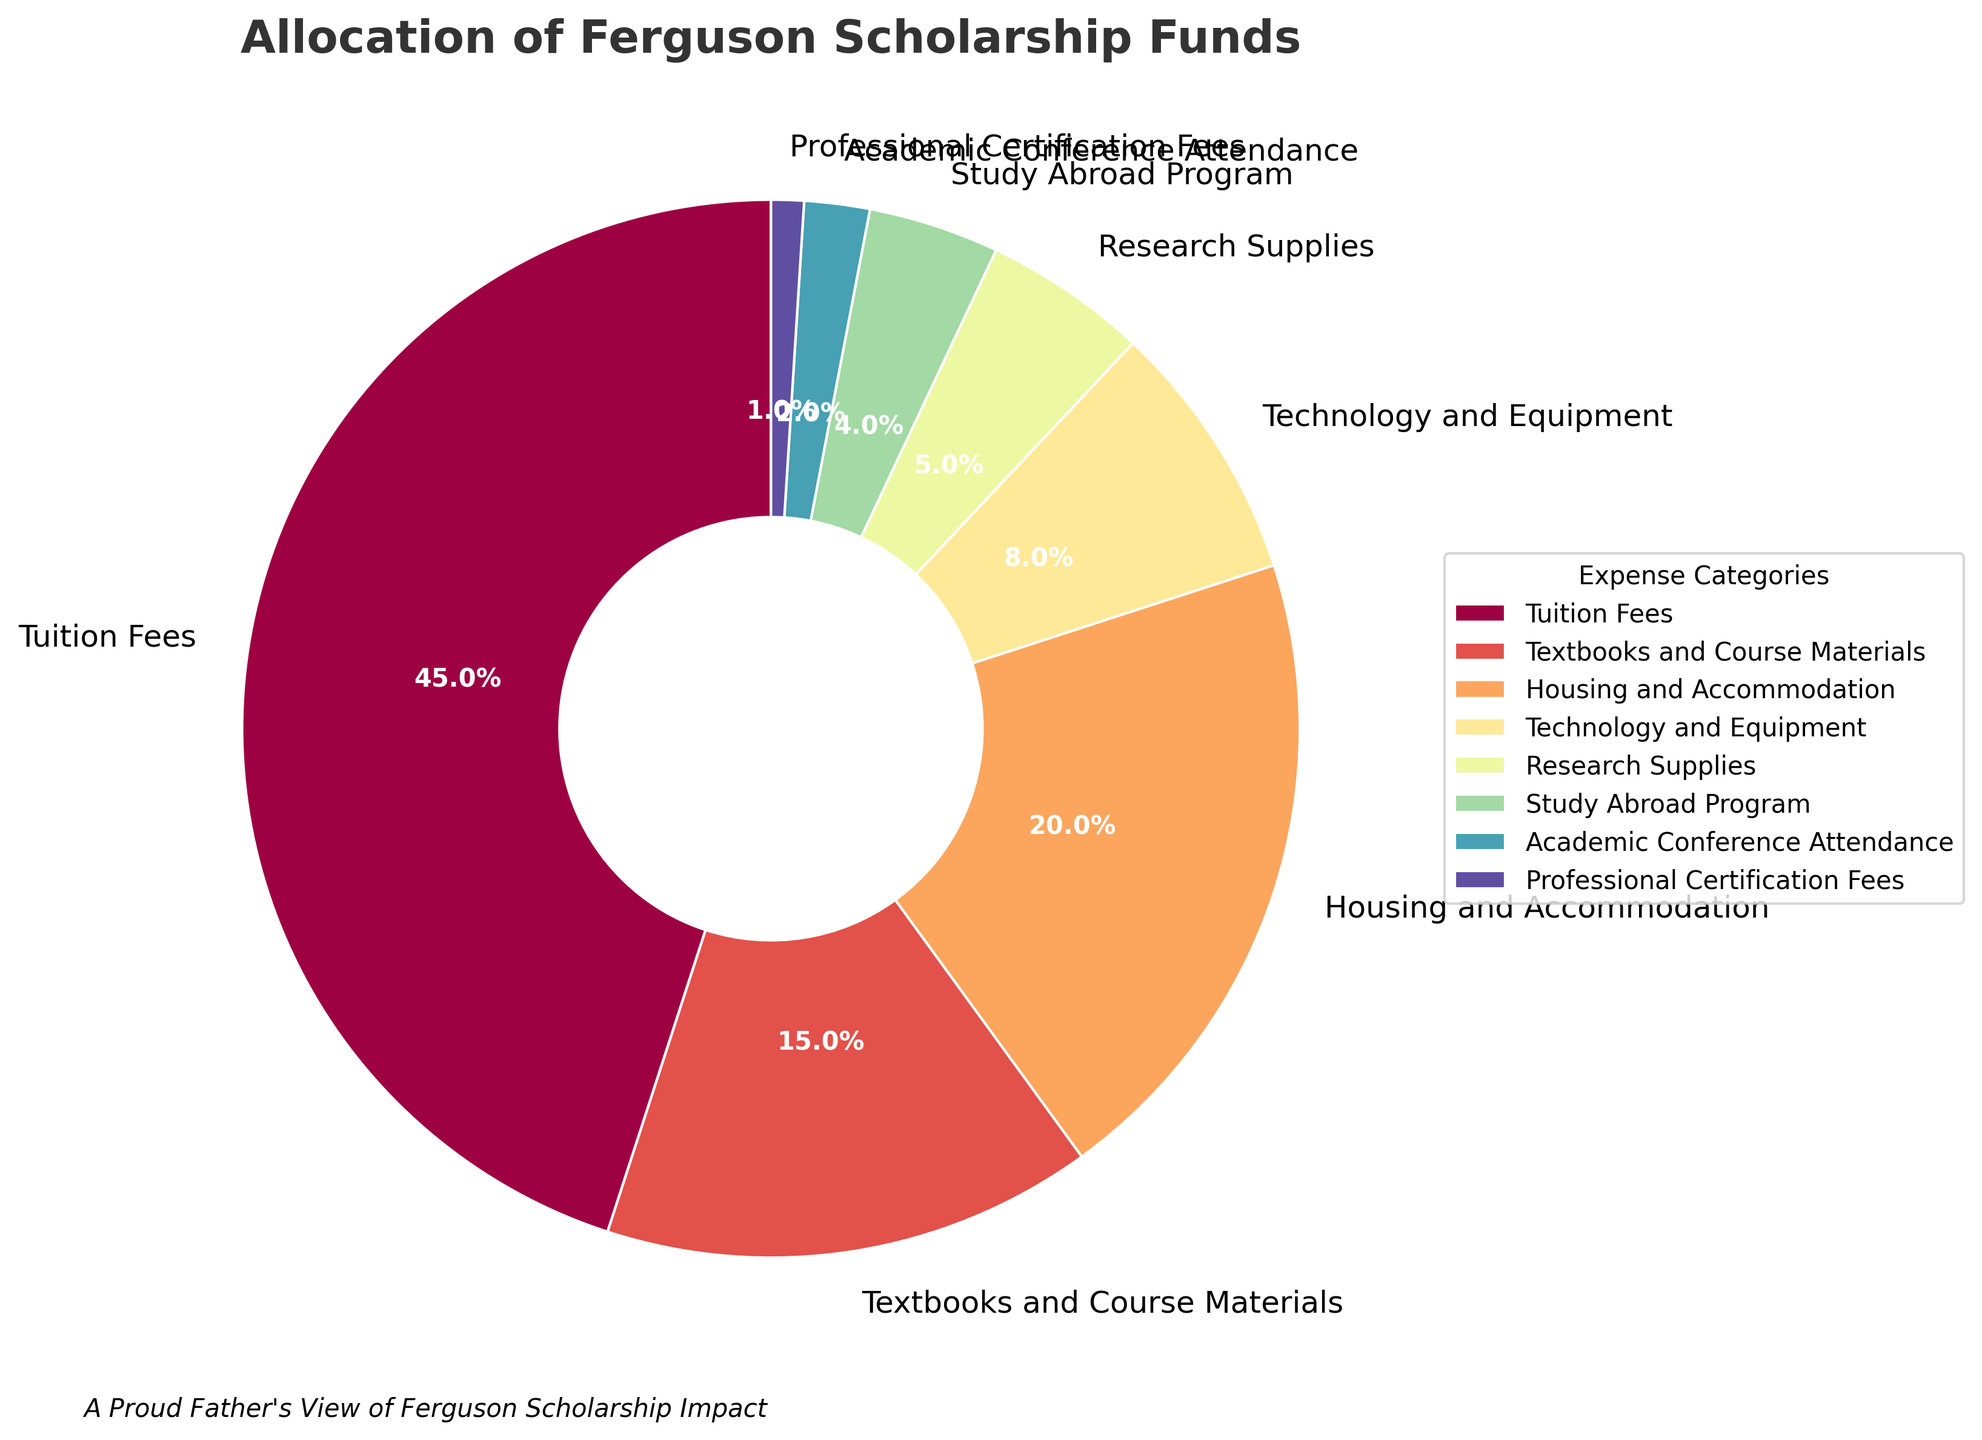What percentage of the scholarship funds is allocated to housing and accommodation compared to textbooks and course materials? The figure shows that housing and accommodation receives 20% of the funds, while textbooks and course materials receive 15%. Comparing these, housing and accommodation has a larger allocation by 5%.
Answer: Housing and accommodation receives 5% more Which expense category receives the least amount of funding? Referring to the figure, the category with the smallest percentage is Professional Certification Fees at 1%.
Answer: Professional Certification Fees Are tuition fees funded more than twice the amount allocated to technology and equipment? Tuition fees receive 45% of the funds, while technology and equipment receive 8%. Since 45% is more than twice (2 * 8% = 16%), tuition fees are indeed funded more than twice the amount allocated to technology and equipment.
Answer: Yes, they are funded more than twice What is the combined percentage of funds allocated to research supplies and study abroad programs? Research supplies receive 5% and study abroad programs receive 4%. Adding these together gives 5% + 4% = 9%.
Answer: 9% What is the total percentage of funds allocated to academic conference attendance and professional certification fees? The figure shows 2% allocated to academic conference attendance and 1% to professional certification fees. Summing these gives 2% + 1% = 3%.
Answer: 3% Which category has a larger percentage: Technology and Equipment or Research Supplies? According to the figure, technology and equipment is allocated 8%, whereas research supplies are allocated 5%. Thus, technology and equipment has a larger percentage.
Answer: Technology and Equipment If the scholarship funds were increased by 10% and all categories received an equal relative increase, what would be the new percentage for textbooks and course materials? First calculate the increase for textbooks and course materials: 15% * 0.1 = 1.5%. Adding this to the original percentage, the new percentage becomes 15% + 1.5% = 16.5%.
Answer: 16.5% What color is used to represent tuition fees in the pie chart? By examining the figure, tuition fees are represented with the first color from the color gradient used. This color is typically at the starting point of the Spectral colormap.
Answer: The color is the first in the gradient (commonly reddish) How much more funding does housing and accommodation receive compared to research supplies and study abroad programs combined? Housing and accommodation receive 20%. Research supplies receive 5%, and study abroad programs receive 4%, combining them gives 5% + 4% = 9%. The difference is 20% - 9% = 11%.
Answer: 11% more 